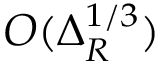<formula> <loc_0><loc_0><loc_500><loc_500>O ( \Delta _ { R } ^ { 1 / 3 } )</formula> 